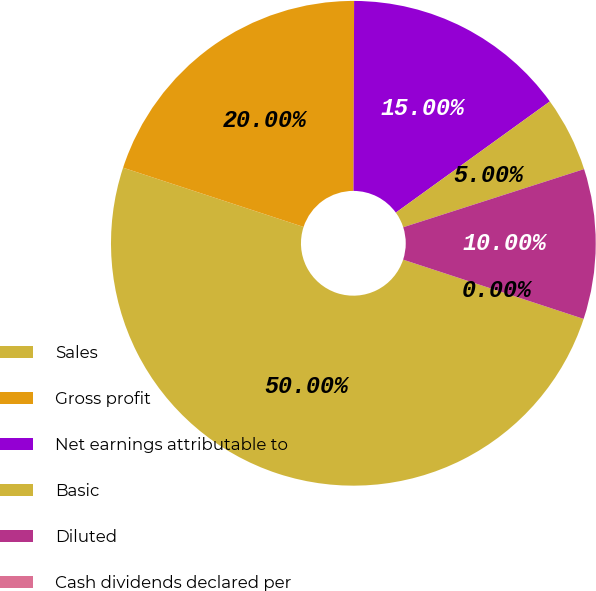<chart> <loc_0><loc_0><loc_500><loc_500><pie_chart><fcel>Sales<fcel>Gross profit<fcel>Net earnings attributable to<fcel>Basic<fcel>Diluted<fcel>Cash dividends declared per<nl><fcel>50.0%<fcel>20.0%<fcel>15.0%<fcel>5.0%<fcel>10.0%<fcel>0.0%<nl></chart> 